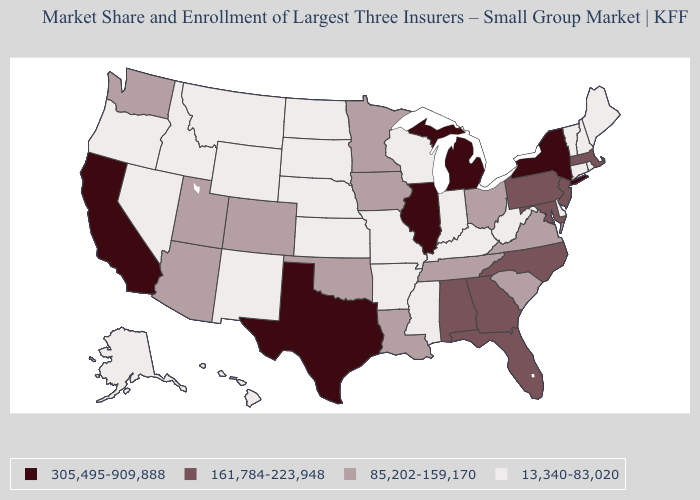What is the value of Louisiana?
Be succinct. 85,202-159,170. Name the states that have a value in the range 161,784-223,948?
Answer briefly. Alabama, Florida, Georgia, Maryland, Massachusetts, New Jersey, North Carolina, Pennsylvania. What is the value of Pennsylvania?
Keep it brief. 161,784-223,948. Name the states that have a value in the range 85,202-159,170?
Quick response, please. Arizona, Colorado, Iowa, Louisiana, Minnesota, Ohio, Oklahoma, South Carolina, Tennessee, Utah, Virginia, Washington. What is the value of Minnesota?
Concise answer only. 85,202-159,170. Does the map have missing data?
Be succinct. No. Name the states that have a value in the range 85,202-159,170?
Give a very brief answer. Arizona, Colorado, Iowa, Louisiana, Minnesota, Ohio, Oklahoma, South Carolina, Tennessee, Utah, Virginia, Washington. What is the value of Oklahoma?
Be succinct. 85,202-159,170. Does California have the highest value in the West?
Give a very brief answer. Yes. What is the value of Montana?
Write a very short answer. 13,340-83,020. Name the states that have a value in the range 85,202-159,170?
Give a very brief answer. Arizona, Colorado, Iowa, Louisiana, Minnesota, Ohio, Oklahoma, South Carolina, Tennessee, Utah, Virginia, Washington. Among the states that border South Dakota , does Nebraska have the lowest value?
Concise answer only. Yes. Name the states that have a value in the range 85,202-159,170?
Answer briefly. Arizona, Colorado, Iowa, Louisiana, Minnesota, Ohio, Oklahoma, South Carolina, Tennessee, Utah, Virginia, Washington. Does Ohio have a lower value than Indiana?
Concise answer only. No. What is the value of Idaho?
Keep it brief. 13,340-83,020. 